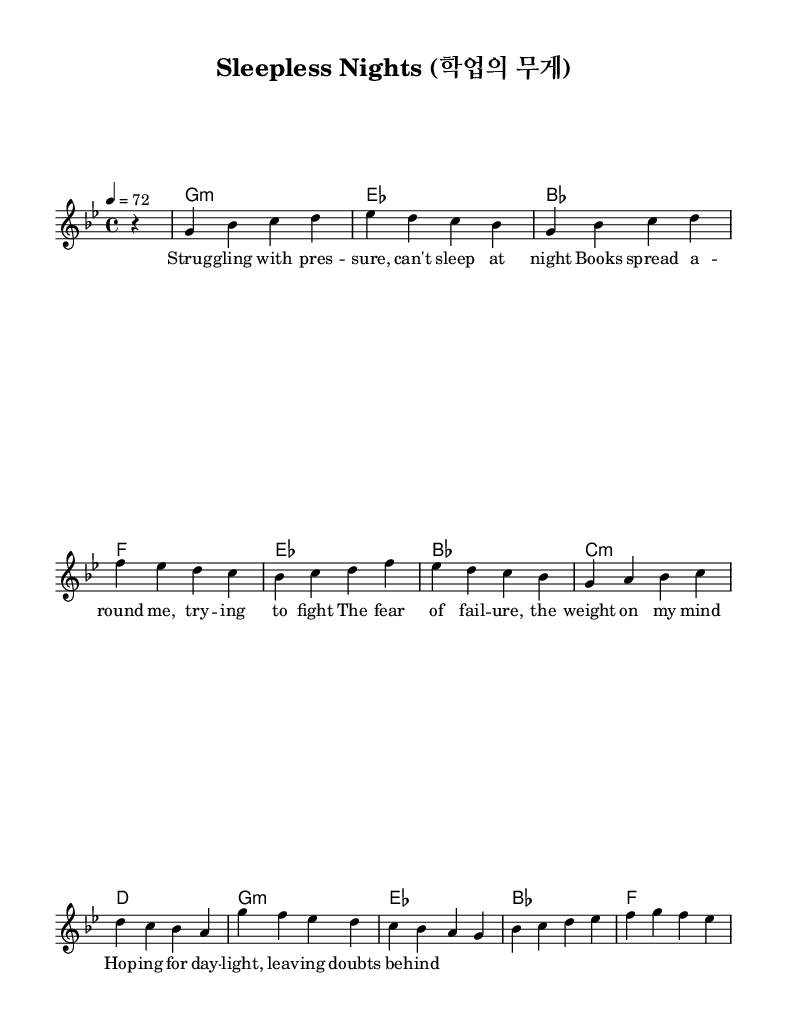What is the key signature of this music? The key signature indicates the tonality of a piece. Here, it shows two flats (B♭ and E♭), which corresponds to G minor.
Answer: G minor What is the time signature of this piece? The time signature is displayed at the beginning of the score, and in this music, it is shown as 4/4, which means there are four beats in each measure.
Answer: 4/4 What is the tempo marking for this sheet music? The tempo is indicated at the beginning of the score with "4 = 72," meaning there are 72 beats per minute, setting a moderate pace for the music.
Answer: 72 How many measures are in the verse section? The verse section consists of four measures, which can be counted directly from the music notation provided for that section.
Answer: 4 What are the chords used in the chorus? The chorus contains four chords: G minor, E♭, B♭, and F. These chords can be seen in the chord mode section specifically for the chorus part.
Answer: G minor, E♭, B♭, F Which theme is primarily expressed in the lyrics? The lyrics reflect themes of academic pressure and sleeplessness, focusing on struggles associated with student life and anxiety, which aligns with the concept of emotional K-Pop ballads.
Answer: Academic pressure How does the melody of this ballad reflect K-Pop characteristics? K-Pop ballads often feature emotional melodies that blend traditional and modern elements; the soaring melodies in the piece, particularly in the chorus, showcase this by using expressive intervals that evoke deep feelings.
Answer: Emotional and expressive 